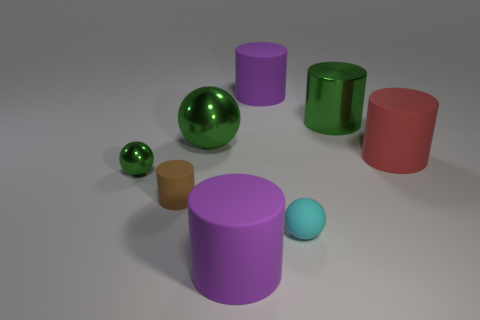Is the color of the big shiny ball the same as the cylinder behind the shiny cylinder?
Ensure brevity in your answer.  No. Is the color of the tiny cylinder the same as the small metallic thing?
Offer a terse response. No. Is the number of purple cylinders less than the number of small yellow cubes?
Make the answer very short. No. How many other things are there of the same color as the big shiny ball?
Offer a terse response. 2. What number of big green cylinders are there?
Give a very brief answer. 1. Is the number of red cylinders on the left side of the large red rubber thing less than the number of tiny purple balls?
Offer a very short reply. No. Is the material of the purple cylinder that is behind the brown thing the same as the green cylinder?
Ensure brevity in your answer.  No. What shape is the large green metallic object in front of the green metal thing on the right side of the big purple object that is behind the big green shiny cylinder?
Offer a very short reply. Sphere. Is there a purple rubber ball of the same size as the cyan rubber thing?
Give a very brief answer. No. What is the size of the brown object?
Provide a short and direct response. Small. 